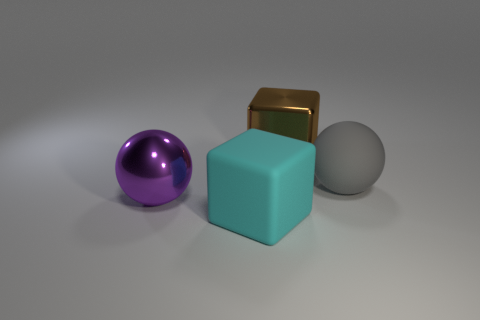Add 1 small yellow metal blocks. How many objects exist? 5 Add 4 big purple spheres. How many big purple spheres exist? 5 Subtract 0 purple cubes. How many objects are left? 4 Subtract all small brown matte cubes. Subtract all metallic things. How many objects are left? 2 Add 4 big purple metal spheres. How many big purple metal spheres are left? 5 